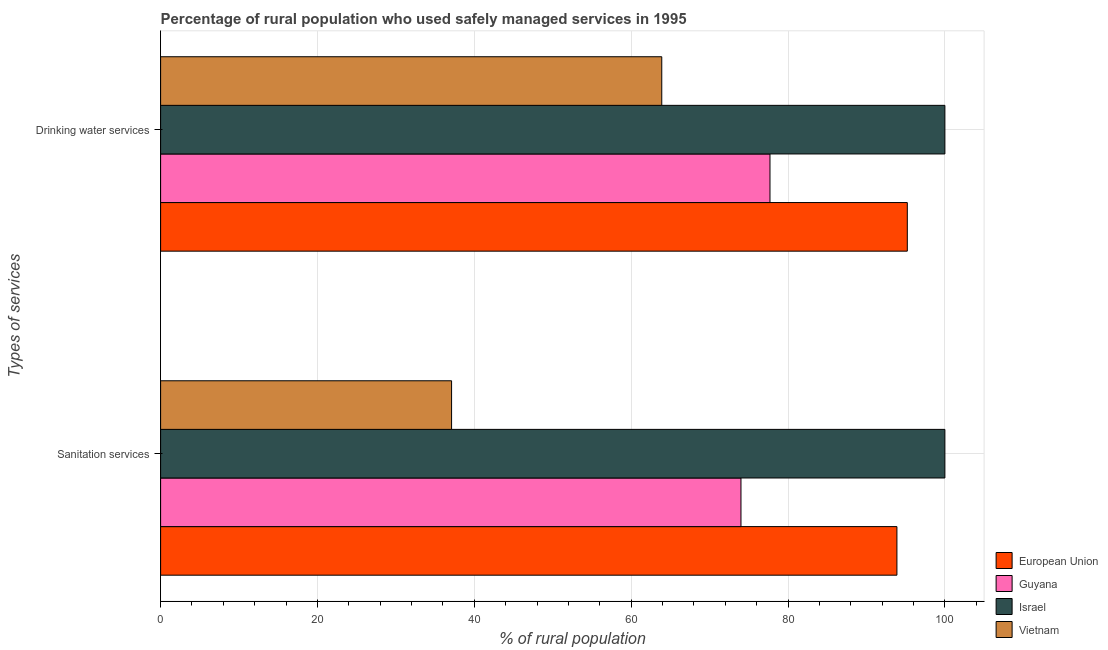How many different coloured bars are there?
Offer a very short reply. 4. Are the number of bars on each tick of the Y-axis equal?
Keep it short and to the point. Yes. How many bars are there on the 1st tick from the bottom?
Offer a very short reply. 4. What is the label of the 1st group of bars from the top?
Provide a short and direct response. Drinking water services. What is the percentage of rural population who used sanitation services in Israel?
Keep it short and to the point. 100. Across all countries, what is the maximum percentage of rural population who used drinking water services?
Give a very brief answer. 100. Across all countries, what is the minimum percentage of rural population who used drinking water services?
Your answer should be very brief. 63.9. In which country was the percentage of rural population who used drinking water services minimum?
Make the answer very short. Vietnam. What is the total percentage of rural population who used drinking water services in the graph?
Provide a succinct answer. 336.81. What is the difference between the percentage of rural population who used sanitation services in European Union and that in Israel?
Offer a very short reply. -6.12. What is the difference between the percentage of rural population who used sanitation services in Vietnam and the percentage of rural population who used drinking water services in European Union?
Give a very brief answer. -58.11. What is the average percentage of rural population who used drinking water services per country?
Ensure brevity in your answer.  84.2. What is the ratio of the percentage of rural population who used drinking water services in European Union to that in Vietnam?
Your response must be concise. 1.49. Is the percentage of rural population who used drinking water services in Vietnam less than that in European Union?
Make the answer very short. Yes. What does the 1st bar from the top in Drinking water services represents?
Provide a succinct answer. Vietnam. What does the 4th bar from the bottom in Sanitation services represents?
Your response must be concise. Vietnam. How many bars are there?
Your response must be concise. 8. Are all the bars in the graph horizontal?
Ensure brevity in your answer.  Yes. What is the difference between two consecutive major ticks on the X-axis?
Offer a very short reply. 20. Does the graph contain grids?
Keep it short and to the point. Yes. How are the legend labels stacked?
Offer a very short reply. Vertical. What is the title of the graph?
Your answer should be compact. Percentage of rural population who used safely managed services in 1995. What is the label or title of the X-axis?
Offer a terse response. % of rural population. What is the label or title of the Y-axis?
Keep it short and to the point. Types of services. What is the % of rural population of European Union in Sanitation services?
Keep it short and to the point. 93.88. What is the % of rural population of Israel in Sanitation services?
Offer a terse response. 100. What is the % of rural population in Vietnam in Sanitation services?
Provide a short and direct response. 37.1. What is the % of rural population of European Union in Drinking water services?
Your response must be concise. 95.21. What is the % of rural population in Guyana in Drinking water services?
Make the answer very short. 77.7. What is the % of rural population in Israel in Drinking water services?
Provide a short and direct response. 100. What is the % of rural population in Vietnam in Drinking water services?
Give a very brief answer. 63.9. Across all Types of services, what is the maximum % of rural population of European Union?
Your answer should be very brief. 95.21. Across all Types of services, what is the maximum % of rural population in Guyana?
Offer a very short reply. 77.7. Across all Types of services, what is the maximum % of rural population of Vietnam?
Offer a very short reply. 63.9. Across all Types of services, what is the minimum % of rural population in European Union?
Your answer should be very brief. 93.88. Across all Types of services, what is the minimum % of rural population of Vietnam?
Your answer should be compact. 37.1. What is the total % of rural population of European Union in the graph?
Your response must be concise. 189.09. What is the total % of rural population of Guyana in the graph?
Give a very brief answer. 151.7. What is the total % of rural population in Vietnam in the graph?
Give a very brief answer. 101. What is the difference between the % of rural population of European Union in Sanitation services and that in Drinking water services?
Ensure brevity in your answer.  -1.33. What is the difference between the % of rural population of Vietnam in Sanitation services and that in Drinking water services?
Make the answer very short. -26.8. What is the difference between the % of rural population in European Union in Sanitation services and the % of rural population in Guyana in Drinking water services?
Make the answer very short. 16.18. What is the difference between the % of rural population in European Union in Sanitation services and the % of rural population in Israel in Drinking water services?
Your answer should be very brief. -6.12. What is the difference between the % of rural population in European Union in Sanitation services and the % of rural population in Vietnam in Drinking water services?
Give a very brief answer. 29.98. What is the difference between the % of rural population of Guyana in Sanitation services and the % of rural population of Israel in Drinking water services?
Give a very brief answer. -26. What is the difference between the % of rural population in Guyana in Sanitation services and the % of rural population in Vietnam in Drinking water services?
Your answer should be compact. 10.1. What is the difference between the % of rural population of Israel in Sanitation services and the % of rural population of Vietnam in Drinking water services?
Provide a short and direct response. 36.1. What is the average % of rural population of European Union per Types of services?
Make the answer very short. 94.55. What is the average % of rural population in Guyana per Types of services?
Offer a terse response. 75.85. What is the average % of rural population in Israel per Types of services?
Provide a short and direct response. 100. What is the average % of rural population of Vietnam per Types of services?
Your answer should be very brief. 50.5. What is the difference between the % of rural population in European Union and % of rural population in Guyana in Sanitation services?
Offer a very short reply. 19.88. What is the difference between the % of rural population of European Union and % of rural population of Israel in Sanitation services?
Your response must be concise. -6.12. What is the difference between the % of rural population of European Union and % of rural population of Vietnam in Sanitation services?
Your response must be concise. 56.78. What is the difference between the % of rural population in Guyana and % of rural population in Israel in Sanitation services?
Provide a succinct answer. -26. What is the difference between the % of rural population of Guyana and % of rural population of Vietnam in Sanitation services?
Offer a terse response. 36.9. What is the difference between the % of rural population in Israel and % of rural population in Vietnam in Sanitation services?
Ensure brevity in your answer.  62.9. What is the difference between the % of rural population of European Union and % of rural population of Guyana in Drinking water services?
Your answer should be compact. 17.51. What is the difference between the % of rural population of European Union and % of rural population of Israel in Drinking water services?
Your response must be concise. -4.79. What is the difference between the % of rural population of European Union and % of rural population of Vietnam in Drinking water services?
Your answer should be very brief. 31.31. What is the difference between the % of rural population in Guyana and % of rural population in Israel in Drinking water services?
Offer a very short reply. -22.3. What is the difference between the % of rural population of Israel and % of rural population of Vietnam in Drinking water services?
Keep it short and to the point. 36.1. What is the ratio of the % of rural population in European Union in Sanitation services to that in Drinking water services?
Give a very brief answer. 0.99. What is the ratio of the % of rural population of Israel in Sanitation services to that in Drinking water services?
Offer a very short reply. 1. What is the ratio of the % of rural population in Vietnam in Sanitation services to that in Drinking water services?
Your answer should be compact. 0.58. What is the difference between the highest and the second highest % of rural population of European Union?
Ensure brevity in your answer.  1.33. What is the difference between the highest and the second highest % of rural population in Guyana?
Ensure brevity in your answer.  3.7. What is the difference between the highest and the second highest % of rural population of Vietnam?
Provide a succinct answer. 26.8. What is the difference between the highest and the lowest % of rural population of European Union?
Provide a succinct answer. 1.33. What is the difference between the highest and the lowest % of rural population in Guyana?
Offer a terse response. 3.7. What is the difference between the highest and the lowest % of rural population of Israel?
Your answer should be very brief. 0. What is the difference between the highest and the lowest % of rural population in Vietnam?
Your response must be concise. 26.8. 